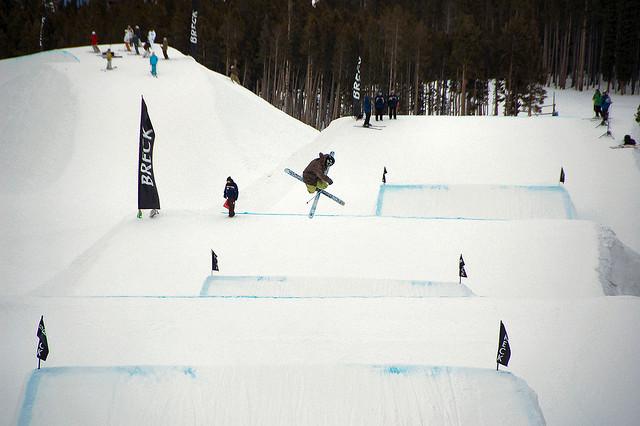Is there snow in the image?
Answer briefly. Yes. What color are the flags?
Give a very brief answer. Black. Is this a winter sport?
Concise answer only. Yes. 